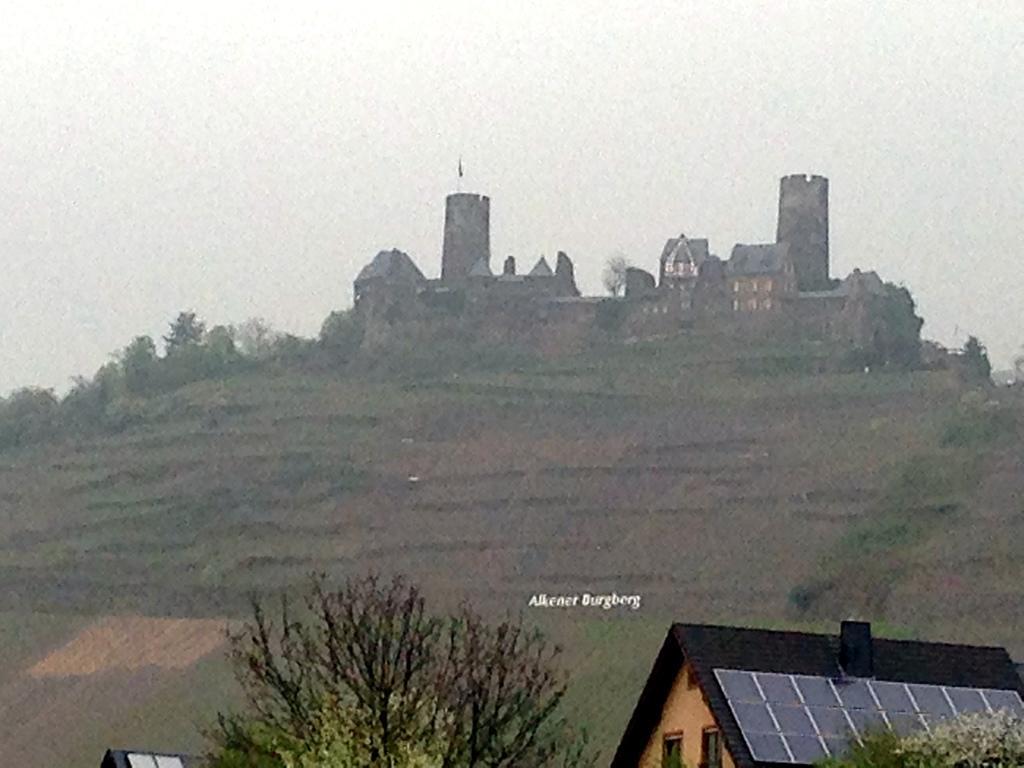Could you give a brief overview of what you see in this image? In this image we can see trees, wooden house, hills, a few more buildings and some text here and sky in the background. 